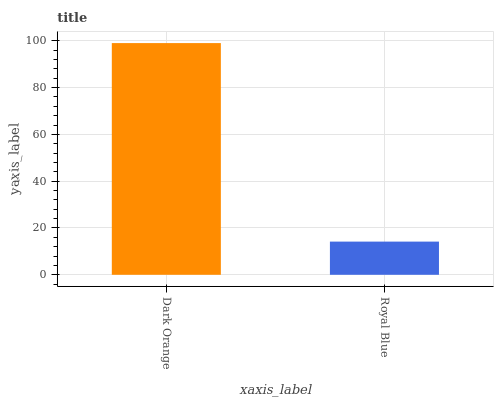Is Royal Blue the minimum?
Answer yes or no. Yes. Is Dark Orange the maximum?
Answer yes or no. Yes. Is Royal Blue the maximum?
Answer yes or no. No. Is Dark Orange greater than Royal Blue?
Answer yes or no. Yes. Is Royal Blue less than Dark Orange?
Answer yes or no. Yes. Is Royal Blue greater than Dark Orange?
Answer yes or no. No. Is Dark Orange less than Royal Blue?
Answer yes or no. No. Is Dark Orange the high median?
Answer yes or no. Yes. Is Royal Blue the low median?
Answer yes or no. Yes. Is Royal Blue the high median?
Answer yes or no. No. Is Dark Orange the low median?
Answer yes or no. No. 